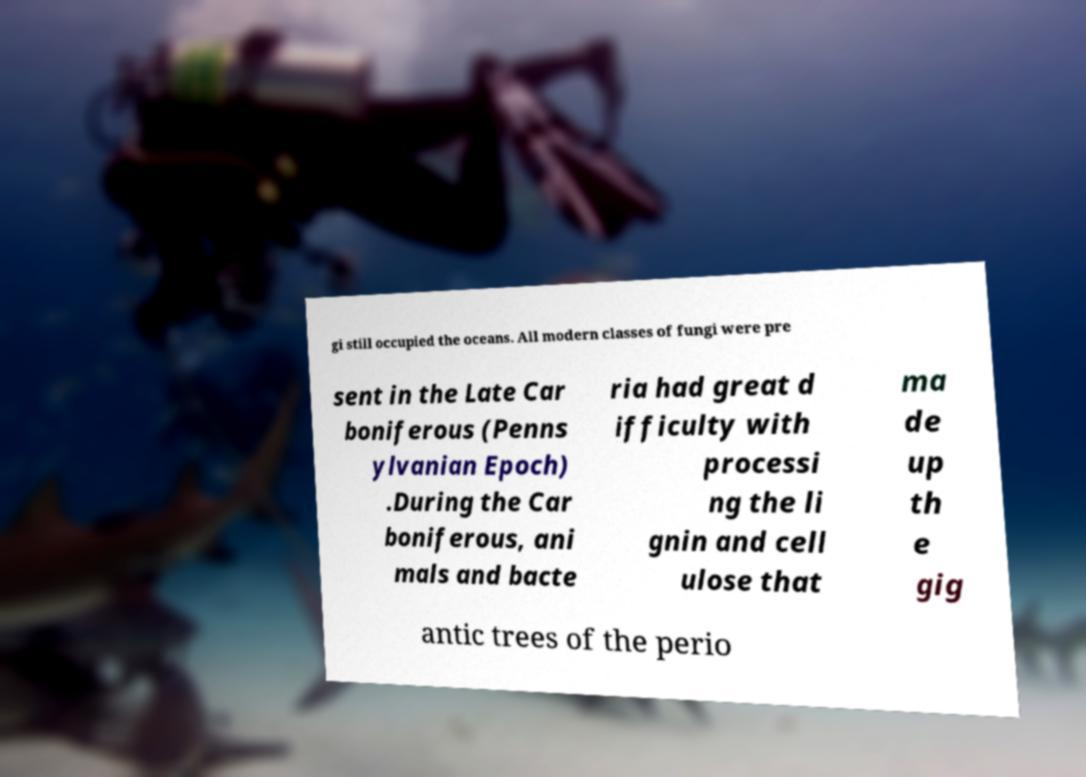Could you assist in decoding the text presented in this image and type it out clearly? gi still occupied the oceans. All modern classes of fungi were pre sent in the Late Car boniferous (Penns ylvanian Epoch) .During the Car boniferous, ani mals and bacte ria had great d ifficulty with processi ng the li gnin and cell ulose that ma de up th e gig antic trees of the perio 